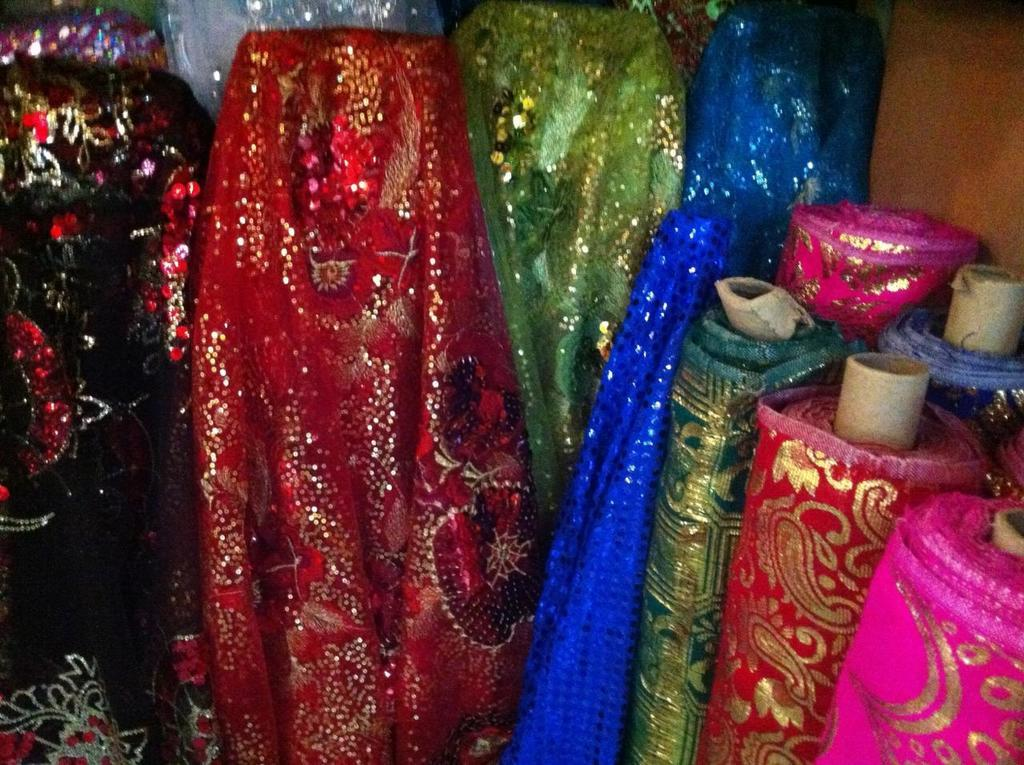What type of items can be seen in the image? There are clothes visible in the image. What type of eggnog can be seen in the image? There is no eggnog present in the image. What type of arch can be seen in the image? There is no arch present in the image. 